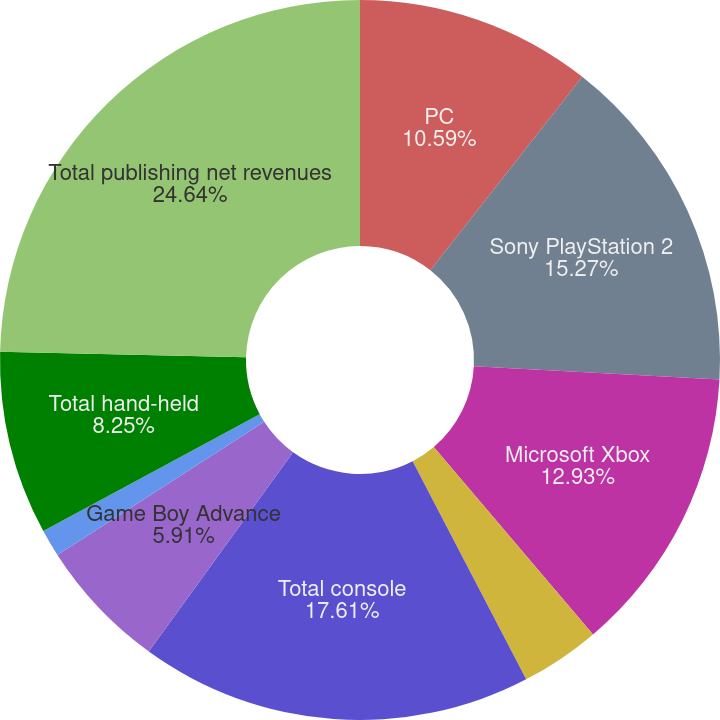<chart> <loc_0><loc_0><loc_500><loc_500><pie_chart><fcel>PC<fcel>Sony PlayStation 2<fcel>Microsoft Xbox<fcel>Nintendo GameCube<fcel>Total console<fcel>Game Boy Advance<fcel>PlayStation Portable<fcel>Total hand-held<fcel>Total publishing net revenues<nl><fcel>10.59%<fcel>15.27%<fcel>12.93%<fcel>3.57%<fcel>17.61%<fcel>5.91%<fcel>1.23%<fcel>8.25%<fcel>24.63%<nl></chart> 